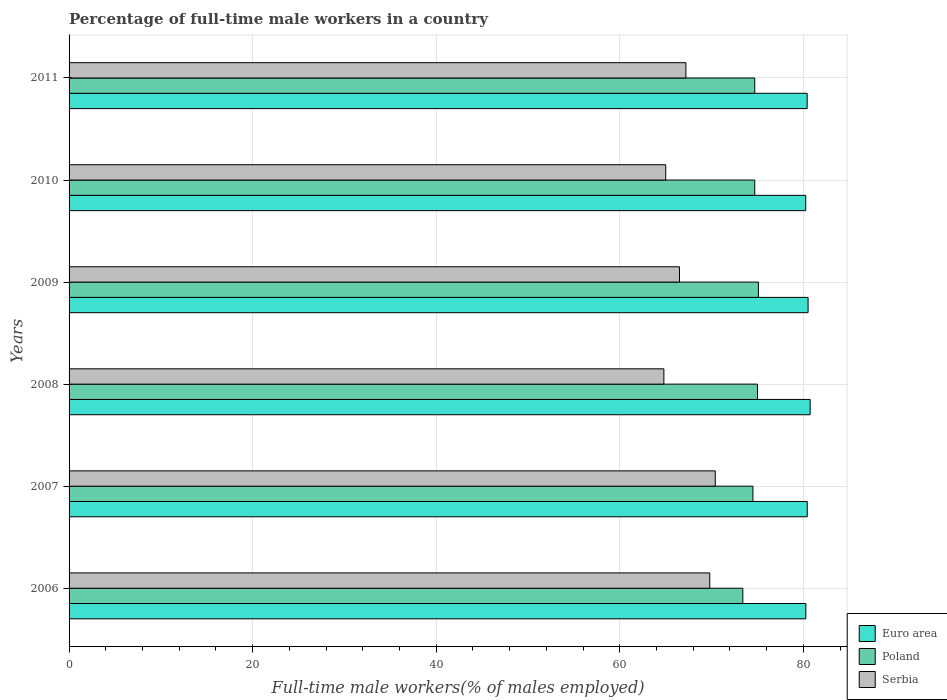How many different coloured bars are there?
Your answer should be compact. 3. Are the number of bars per tick equal to the number of legend labels?
Offer a very short reply. Yes. Are the number of bars on each tick of the Y-axis equal?
Provide a short and direct response. Yes. In how many cases, is the number of bars for a given year not equal to the number of legend labels?
Keep it short and to the point. 0. What is the percentage of full-time male workers in Serbia in 2008?
Give a very brief answer. 64.8. Across all years, what is the maximum percentage of full-time male workers in Serbia?
Your answer should be very brief. 70.4. Across all years, what is the minimum percentage of full-time male workers in Euro area?
Provide a short and direct response. 80.25. In which year was the percentage of full-time male workers in Poland maximum?
Keep it short and to the point. 2009. What is the total percentage of full-time male workers in Serbia in the graph?
Offer a terse response. 403.7. What is the difference between the percentage of full-time male workers in Poland in 2006 and that in 2010?
Provide a short and direct response. -1.3. What is the difference between the percentage of full-time male workers in Euro area in 2006 and the percentage of full-time male workers in Poland in 2009?
Provide a short and direct response. 5.17. What is the average percentage of full-time male workers in Serbia per year?
Make the answer very short. 67.28. In the year 2009, what is the difference between the percentage of full-time male workers in Poland and percentage of full-time male workers in Serbia?
Offer a very short reply. 8.6. What is the ratio of the percentage of full-time male workers in Serbia in 2006 to that in 2011?
Provide a succinct answer. 1.04. Is the percentage of full-time male workers in Poland in 2009 less than that in 2010?
Keep it short and to the point. No. What is the difference between the highest and the second highest percentage of full-time male workers in Serbia?
Your answer should be very brief. 0.6. What is the difference between the highest and the lowest percentage of full-time male workers in Poland?
Give a very brief answer. 1.7. What does the 1st bar from the top in 2008 represents?
Offer a very short reply. Serbia. Is it the case that in every year, the sum of the percentage of full-time male workers in Poland and percentage of full-time male workers in Euro area is greater than the percentage of full-time male workers in Serbia?
Offer a terse response. Yes. How many bars are there?
Your response must be concise. 18. Are all the bars in the graph horizontal?
Your answer should be compact. Yes. What is the difference between two consecutive major ticks on the X-axis?
Offer a very short reply. 20. Does the graph contain grids?
Offer a terse response. Yes. Where does the legend appear in the graph?
Give a very brief answer. Bottom right. How many legend labels are there?
Provide a short and direct response. 3. What is the title of the graph?
Provide a succinct answer. Percentage of full-time male workers in a country. Does "Panama" appear as one of the legend labels in the graph?
Offer a terse response. No. What is the label or title of the X-axis?
Provide a short and direct response. Full-time male workers(% of males employed). What is the label or title of the Y-axis?
Keep it short and to the point. Years. What is the Full-time male workers(% of males employed) of Euro area in 2006?
Provide a succinct answer. 80.27. What is the Full-time male workers(% of males employed) of Poland in 2006?
Offer a terse response. 73.4. What is the Full-time male workers(% of males employed) in Serbia in 2006?
Your answer should be very brief. 69.8. What is the Full-time male workers(% of males employed) of Euro area in 2007?
Provide a short and direct response. 80.42. What is the Full-time male workers(% of males employed) in Poland in 2007?
Ensure brevity in your answer.  74.5. What is the Full-time male workers(% of males employed) of Serbia in 2007?
Provide a succinct answer. 70.4. What is the Full-time male workers(% of males employed) of Euro area in 2008?
Offer a terse response. 80.74. What is the Full-time male workers(% of males employed) of Poland in 2008?
Make the answer very short. 75. What is the Full-time male workers(% of males employed) in Serbia in 2008?
Make the answer very short. 64.8. What is the Full-time male workers(% of males employed) in Euro area in 2009?
Your response must be concise. 80.51. What is the Full-time male workers(% of males employed) of Poland in 2009?
Offer a very short reply. 75.1. What is the Full-time male workers(% of males employed) in Serbia in 2009?
Make the answer very short. 66.5. What is the Full-time male workers(% of males employed) of Euro area in 2010?
Provide a short and direct response. 80.25. What is the Full-time male workers(% of males employed) of Poland in 2010?
Keep it short and to the point. 74.7. What is the Full-time male workers(% of males employed) in Serbia in 2010?
Make the answer very short. 65. What is the Full-time male workers(% of males employed) in Euro area in 2011?
Your answer should be compact. 80.41. What is the Full-time male workers(% of males employed) of Poland in 2011?
Your answer should be very brief. 74.7. What is the Full-time male workers(% of males employed) of Serbia in 2011?
Keep it short and to the point. 67.2. Across all years, what is the maximum Full-time male workers(% of males employed) of Euro area?
Give a very brief answer. 80.74. Across all years, what is the maximum Full-time male workers(% of males employed) in Poland?
Your answer should be very brief. 75.1. Across all years, what is the maximum Full-time male workers(% of males employed) in Serbia?
Keep it short and to the point. 70.4. Across all years, what is the minimum Full-time male workers(% of males employed) in Euro area?
Your answer should be compact. 80.25. Across all years, what is the minimum Full-time male workers(% of males employed) of Poland?
Make the answer very short. 73.4. Across all years, what is the minimum Full-time male workers(% of males employed) of Serbia?
Ensure brevity in your answer.  64.8. What is the total Full-time male workers(% of males employed) in Euro area in the graph?
Your response must be concise. 482.59. What is the total Full-time male workers(% of males employed) of Poland in the graph?
Your response must be concise. 447.4. What is the total Full-time male workers(% of males employed) of Serbia in the graph?
Ensure brevity in your answer.  403.7. What is the difference between the Full-time male workers(% of males employed) of Euro area in 2006 and that in 2007?
Give a very brief answer. -0.15. What is the difference between the Full-time male workers(% of males employed) in Poland in 2006 and that in 2007?
Your answer should be compact. -1.1. What is the difference between the Full-time male workers(% of males employed) in Serbia in 2006 and that in 2007?
Your answer should be very brief. -0.6. What is the difference between the Full-time male workers(% of males employed) in Euro area in 2006 and that in 2008?
Offer a very short reply. -0.47. What is the difference between the Full-time male workers(% of males employed) in Poland in 2006 and that in 2008?
Your answer should be very brief. -1.6. What is the difference between the Full-time male workers(% of males employed) in Euro area in 2006 and that in 2009?
Offer a very short reply. -0.24. What is the difference between the Full-time male workers(% of males employed) in Serbia in 2006 and that in 2009?
Keep it short and to the point. 3.3. What is the difference between the Full-time male workers(% of males employed) in Euro area in 2006 and that in 2010?
Make the answer very short. 0.02. What is the difference between the Full-time male workers(% of males employed) of Poland in 2006 and that in 2010?
Offer a terse response. -1.3. What is the difference between the Full-time male workers(% of males employed) of Euro area in 2006 and that in 2011?
Your answer should be compact. -0.14. What is the difference between the Full-time male workers(% of males employed) in Poland in 2006 and that in 2011?
Keep it short and to the point. -1.3. What is the difference between the Full-time male workers(% of males employed) of Serbia in 2006 and that in 2011?
Ensure brevity in your answer.  2.6. What is the difference between the Full-time male workers(% of males employed) of Euro area in 2007 and that in 2008?
Make the answer very short. -0.32. What is the difference between the Full-time male workers(% of males employed) in Euro area in 2007 and that in 2009?
Your answer should be very brief. -0.09. What is the difference between the Full-time male workers(% of males employed) of Serbia in 2007 and that in 2009?
Provide a succinct answer. 3.9. What is the difference between the Full-time male workers(% of males employed) in Euro area in 2007 and that in 2010?
Ensure brevity in your answer.  0.17. What is the difference between the Full-time male workers(% of males employed) of Poland in 2007 and that in 2010?
Provide a succinct answer. -0.2. What is the difference between the Full-time male workers(% of males employed) of Serbia in 2007 and that in 2010?
Provide a succinct answer. 5.4. What is the difference between the Full-time male workers(% of males employed) of Euro area in 2007 and that in 2011?
Offer a very short reply. 0.01. What is the difference between the Full-time male workers(% of males employed) of Serbia in 2007 and that in 2011?
Offer a very short reply. 3.2. What is the difference between the Full-time male workers(% of males employed) in Euro area in 2008 and that in 2009?
Offer a terse response. 0.23. What is the difference between the Full-time male workers(% of males employed) in Poland in 2008 and that in 2009?
Make the answer very short. -0.1. What is the difference between the Full-time male workers(% of males employed) of Euro area in 2008 and that in 2010?
Keep it short and to the point. 0.49. What is the difference between the Full-time male workers(% of males employed) in Serbia in 2008 and that in 2010?
Offer a very short reply. -0.2. What is the difference between the Full-time male workers(% of males employed) of Euro area in 2008 and that in 2011?
Give a very brief answer. 0.33. What is the difference between the Full-time male workers(% of males employed) in Serbia in 2008 and that in 2011?
Ensure brevity in your answer.  -2.4. What is the difference between the Full-time male workers(% of males employed) of Euro area in 2009 and that in 2010?
Your answer should be very brief. 0.26. What is the difference between the Full-time male workers(% of males employed) of Poland in 2009 and that in 2010?
Make the answer very short. 0.4. What is the difference between the Full-time male workers(% of males employed) of Serbia in 2009 and that in 2010?
Your answer should be very brief. 1.5. What is the difference between the Full-time male workers(% of males employed) of Euro area in 2009 and that in 2011?
Your answer should be compact. 0.1. What is the difference between the Full-time male workers(% of males employed) of Serbia in 2009 and that in 2011?
Give a very brief answer. -0.7. What is the difference between the Full-time male workers(% of males employed) of Euro area in 2010 and that in 2011?
Give a very brief answer. -0.16. What is the difference between the Full-time male workers(% of males employed) in Serbia in 2010 and that in 2011?
Make the answer very short. -2.2. What is the difference between the Full-time male workers(% of males employed) in Euro area in 2006 and the Full-time male workers(% of males employed) in Poland in 2007?
Ensure brevity in your answer.  5.77. What is the difference between the Full-time male workers(% of males employed) of Euro area in 2006 and the Full-time male workers(% of males employed) of Serbia in 2007?
Your response must be concise. 9.87. What is the difference between the Full-time male workers(% of males employed) in Poland in 2006 and the Full-time male workers(% of males employed) in Serbia in 2007?
Keep it short and to the point. 3. What is the difference between the Full-time male workers(% of males employed) of Euro area in 2006 and the Full-time male workers(% of males employed) of Poland in 2008?
Give a very brief answer. 5.27. What is the difference between the Full-time male workers(% of males employed) of Euro area in 2006 and the Full-time male workers(% of males employed) of Serbia in 2008?
Your answer should be very brief. 15.47. What is the difference between the Full-time male workers(% of males employed) of Euro area in 2006 and the Full-time male workers(% of males employed) of Poland in 2009?
Make the answer very short. 5.17. What is the difference between the Full-time male workers(% of males employed) in Euro area in 2006 and the Full-time male workers(% of males employed) in Serbia in 2009?
Make the answer very short. 13.77. What is the difference between the Full-time male workers(% of males employed) of Poland in 2006 and the Full-time male workers(% of males employed) of Serbia in 2009?
Give a very brief answer. 6.9. What is the difference between the Full-time male workers(% of males employed) in Euro area in 2006 and the Full-time male workers(% of males employed) in Poland in 2010?
Your response must be concise. 5.57. What is the difference between the Full-time male workers(% of males employed) of Euro area in 2006 and the Full-time male workers(% of males employed) of Serbia in 2010?
Provide a succinct answer. 15.27. What is the difference between the Full-time male workers(% of males employed) in Euro area in 2006 and the Full-time male workers(% of males employed) in Poland in 2011?
Ensure brevity in your answer.  5.57. What is the difference between the Full-time male workers(% of males employed) of Euro area in 2006 and the Full-time male workers(% of males employed) of Serbia in 2011?
Your answer should be compact. 13.07. What is the difference between the Full-time male workers(% of males employed) in Poland in 2006 and the Full-time male workers(% of males employed) in Serbia in 2011?
Your response must be concise. 6.2. What is the difference between the Full-time male workers(% of males employed) of Euro area in 2007 and the Full-time male workers(% of males employed) of Poland in 2008?
Provide a short and direct response. 5.42. What is the difference between the Full-time male workers(% of males employed) in Euro area in 2007 and the Full-time male workers(% of males employed) in Serbia in 2008?
Offer a terse response. 15.62. What is the difference between the Full-time male workers(% of males employed) in Poland in 2007 and the Full-time male workers(% of males employed) in Serbia in 2008?
Provide a succinct answer. 9.7. What is the difference between the Full-time male workers(% of males employed) of Euro area in 2007 and the Full-time male workers(% of males employed) of Poland in 2009?
Ensure brevity in your answer.  5.32. What is the difference between the Full-time male workers(% of males employed) in Euro area in 2007 and the Full-time male workers(% of males employed) in Serbia in 2009?
Offer a very short reply. 13.92. What is the difference between the Full-time male workers(% of males employed) in Euro area in 2007 and the Full-time male workers(% of males employed) in Poland in 2010?
Make the answer very short. 5.72. What is the difference between the Full-time male workers(% of males employed) of Euro area in 2007 and the Full-time male workers(% of males employed) of Serbia in 2010?
Offer a terse response. 15.42. What is the difference between the Full-time male workers(% of males employed) of Euro area in 2007 and the Full-time male workers(% of males employed) of Poland in 2011?
Make the answer very short. 5.72. What is the difference between the Full-time male workers(% of males employed) in Euro area in 2007 and the Full-time male workers(% of males employed) in Serbia in 2011?
Provide a succinct answer. 13.22. What is the difference between the Full-time male workers(% of males employed) of Poland in 2007 and the Full-time male workers(% of males employed) of Serbia in 2011?
Offer a terse response. 7.3. What is the difference between the Full-time male workers(% of males employed) of Euro area in 2008 and the Full-time male workers(% of males employed) of Poland in 2009?
Offer a very short reply. 5.64. What is the difference between the Full-time male workers(% of males employed) of Euro area in 2008 and the Full-time male workers(% of males employed) of Serbia in 2009?
Provide a succinct answer. 14.24. What is the difference between the Full-time male workers(% of males employed) of Euro area in 2008 and the Full-time male workers(% of males employed) of Poland in 2010?
Offer a terse response. 6.04. What is the difference between the Full-time male workers(% of males employed) of Euro area in 2008 and the Full-time male workers(% of males employed) of Serbia in 2010?
Offer a very short reply. 15.74. What is the difference between the Full-time male workers(% of males employed) of Euro area in 2008 and the Full-time male workers(% of males employed) of Poland in 2011?
Provide a short and direct response. 6.04. What is the difference between the Full-time male workers(% of males employed) of Euro area in 2008 and the Full-time male workers(% of males employed) of Serbia in 2011?
Offer a terse response. 13.54. What is the difference between the Full-time male workers(% of males employed) in Poland in 2008 and the Full-time male workers(% of males employed) in Serbia in 2011?
Provide a short and direct response. 7.8. What is the difference between the Full-time male workers(% of males employed) in Euro area in 2009 and the Full-time male workers(% of males employed) in Poland in 2010?
Make the answer very short. 5.81. What is the difference between the Full-time male workers(% of males employed) in Euro area in 2009 and the Full-time male workers(% of males employed) in Serbia in 2010?
Your answer should be compact. 15.51. What is the difference between the Full-time male workers(% of males employed) of Euro area in 2009 and the Full-time male workers(% of males employed) of Poland in 2011?
Ensure brevity in your answer.  5.81. What is the difference between the Full-time male workers(% of males employed) of Euro area in 2009 and the Full-time male workers(% of males employed) of Serbia in 2011?
Ensure brevity in your answer.  13.31. What is the difference between the Full-time male workers(% of males employed) of Euro area in 2010 and the Full-time male workers(% of males employed) of Poland in 2011?
Your response must be concise. 5.55. What is the difference between the Full-time male workers(% of males employed) of Euro area in 2010 and the Full-time male workers(% of males employed) of Serbia in 2011?
Your answer should be very brief. 13.05. What is the difference between the Full-time male workers(% of males employed) of Poland in 2010 and the Full-time male workers(% of males employed) of Serbia in 2011?
Your answer should be very brief. 7.5. What is the average Full-time male workers(% of males employed) in Euro area per year?
Ensure brevity in your answer.  80.43. What is the average Full-time male workers(% of males employed) of Poland per year?
Your answer should be very brief. 74.57. What is the average Full-time male workers(% of males employed) in Serbia per year?
Your answer should be very brief. 67.28. In the year 2006, what is the difference between the Full-time male workers(% of males employed) in Euro area and Full-time male workers(% of males employed) in Poland?
Make the answer very short. 6.87. In the year 2006, what is the difference between the Full-time male workers(% of males employed) in Euro area and Full-time male workers(% of males employed) in Serbia?
Keep it short and to the point. 10.47. In the year 2006, what is the difference between the Full-time male workers(% of males employed) in Poland and Full-time male workers(% of males employed) in Serbia?
Offer a terse response. 3.6. In the year 2007, what is the difference between the Full-time male workers(% of males employed) in Euro area and Full-time male workers(% of males employed) in Poland?
Make the answer very short. 5.92. In the year 2007, what is the difference between the Full-time male workers(% of males employed) in Euro area and Full-time male workers(% of males employed) in Serbia?
Keep it short and to the point. 10.02. In the year 2007, what is the difference between the Full-time male workers(% of males employed) of Poland and Full-time male workers(% of males employed) of Serbia?
Keep it short and to the point. 4.1. In the year 2008, what is the difference between the Full-time male workers(% of males employed) in Euro area and Full-time male workers(% of males employed) in Poland?
Provide a short and direct response. 5.74. In the year 2008, what is the difference between the Full-time male workers(% of males employed) of Euro area and Full-time male workers(% of males employed) of Serbia?
Offer a very short reply. 15.94. In the year 2009, what is the difference between the Full-time male workers(% of males employed) in Euro area and Full-time male workers(% of males employed) in Poland?
Ensure brevity in your answer.  5.41. In the year 2009, what is the difference between the Full-time male workers(% of males employed) of Euro area and Full-time male workers(% of males employed) of Serbia?
Provide a succinct answer. 14.01. In the year 2010, what is the difference between the Full-time male workers(% of males employed) in Euro area and Full-time male workers(% of males employed) in Poland?
Make the answer very short. 5.55. In the year 2010, what is the difference between the Full-time male workers(% of males employed) in Euro area and Full-time male workers(% of males employed) in Serbia?
Ensure brevity in your answer.  15.25. In the year 2010, what is the difference between the Full-time male workers(% of males employed) of Poland and Full-time male workers(% of males employed) of Serbia?
Your response must be concise. 9.7. In the year 2011, what is the difference between the Full-time male workers(% of males employed) of Euro area and Full-time male workers(% of males employed) of Poland?
Your response must be concise. 5.71. In the year 2011, what is the difference between the Full-time male workers(% of males employed) in Euro area and Full-time male workers(% of males employed) in Serbia?
Give a very brief answer. 13.21. In the year 2011, what is the difference between the Full-time male workers(% of males employed) in Poland and Full-time male workers(% of males employed) in Serbia?
Provide a short and direct response. 7.5. What is the ratio of the Full-time male workers(% of males employed) in Poland in 2006 to that in 2007?
Ensure brevity in your answer.  0.99. What is the ratio of the Full-time male workers(% of males employed) of Poland in 2006 to that in 2008?
Your response must be concise. 0.98. What is the ratio of the Full-time male workers(% of males employed) of Serbia in 2006 to that in 2008?
Keep it short and to the point. 1.08. What is the ratio of the Full-time male workers(% of males employed) of Poland in 2006 to that in 2009?
Provide a short and direct response. 0.98. What is the ratio of the Full-time male workers(% of males employed) of Serbia in 2006 to that in 2009?
Give a very brief answer. 1.05. What is the ratio of the Full-time male workers(% of males employed) in Poland in 2006 to that in 2010?
Your answer should be compact. 0.98. What is the ratio of the Full-time male workers(% of males employed) of Serbia in 2006 to that in 2010?
Offer a terse response. 1.07. What is the ratio of the Full-time male workers(% of males employed) in Euro area in 2006 to that in 2011?
Your response must be concise. 1. What is the ratio of the Full-time male workers(% of males employed) in Poland in 2006 to that in 2011?
Provide a short and direct response. 0.98. What is the ratio of the Full-time male workers(% of males employed) in Serbia in 2006 to that in 2011?
Keep it short and to the point. 1.04. What is the ratio of the Full-time male workers(% of males employed) of Euro area in 2007 to that in 2008?
Make the answer very short. 1. What is the ratio of the Full-time male workers(% of males employed) of Serbia in 2007 to that in 2008?
Offer a terse response. 1.09. What is the ratio of the Full-time male workers(% of males employed) in Euro area in 2007 to that in 2009?
Provide a succinct answer. 1. What is the ratio of the Full-time male workers(% of males employed) in Serbia in 2007 to that in 2009?
Your answer should be very brief. 1.06. What is the ratio of the Full-time male workers(% of males employed) in Serbia in 2007 to that in 2010?
Offer a terse response. 1.08. What is the ratio of the Full-time male workers(% of males employed) in Poland in 2007 to that in 2011?
Keep it short and to the point. 1. What is the ratio of the Full-time male workers(% of males employed) of Serbia in 2007 to that in 2011?
Your answer should be very brief. 1.05. What is the ratio of the Full-time male workers(% of males employed) of Euro area in 2008 to that in 2009?
Provide a succinct answer. 1. What is the ratio of the Full-time male workers(% of males employed) of Poland in 2008 to that in 2009?
Keep it short and to the point. 1. What is the ratio of the Full-time male workers(% of males employed) of Serbia in 2008 to that in 2009?
Make the answer very short. 0.97. What is the ratio of the Full-time male workers(% of males employed) in Poland in 2008 to that in 2010?
Keep it short and to the point. 1. What is the ratio of the Full-time male workers(% of males employed) of Serbia in 2008 to that in 2010?
Your answer should be compact. 1. What is the ratio of the Full-time male workers(% of males employed) in Serbia in 2008 to that in 2011?
Keep it short and to the point. 0.96. What is the ratio of the Full-time male workers(% of males employed) in Poland in 2009 to that in 2010?
Keep it short and to the point. 1.01. What is the ratio of the Full-time male workers(% of males employed) in Serbia in 2009 to that in 2010?
Offer a very short reply. 1.02. What is the ratio of the Full-time male workers(% of males employed) in Euro area in 2009 to that in 2011?
Make the answer very short. 1. What is the ratio of the Full-time male workers(% of males employed) in Poland in 2009 to that in 2011?
Offer a terse response. 1.01. What is the ratio of the Full-time male workers(% of males employed) of Serbia in 2009 to that in 2011?
Your answer should be very brief. 0.99. What is the ratio of the Full-time male workers(% of males employed) in Euro area in 2010 to that in 2011?
Offer a terse response. 1. What is the ratio of the Full-time male workers(% of males employed) of Poland in 2010 to that in 2011?
Your response must be concise. 1. What is the ratio of the Full-time male workers(% of males employed) of Serbia in 2010 to that in 2011?
Ensure brevity in your answer.  0.97. What is the difference between the highest and the second highest Full-time male workers(% of males employed) of Euro area?
Ensure brevity in your answer.  0.23. What is the difference between the highest and the second highest Full-time male workers(% of males employed) of Poland?
Give a very brief answer. 0.1. What is the difference between the highest and the lowest Full-time male workers(% of males employed) in Euro area?
Your response must be concise. 0.49. What is the difference between the highest and the lowest Full-time male workers(% of males employed) in Serbia?
Provide a short and direct response. 5.6. 